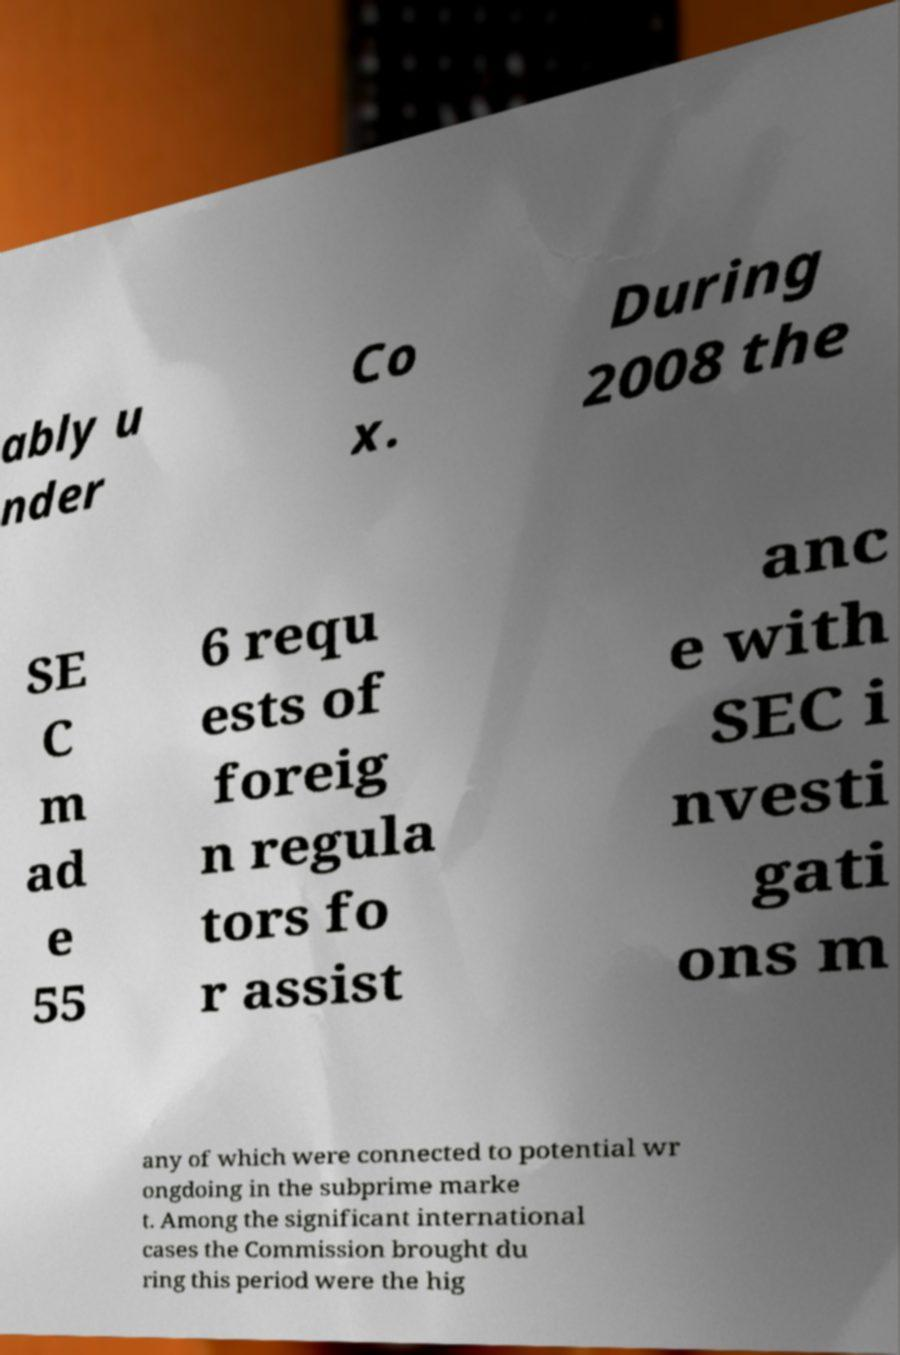Could you extract and type out the text from this image? ably u nder Co x. During 2008 the SE C m ad e 55 6 requ ests of foreig n regula tors fo r assist anc e with SEC i nvesti gati ons m any of which were connected to potential wr ongdoing in the subprime marke t. Among the significant international cases the Commission brought du ring this period were the hig 